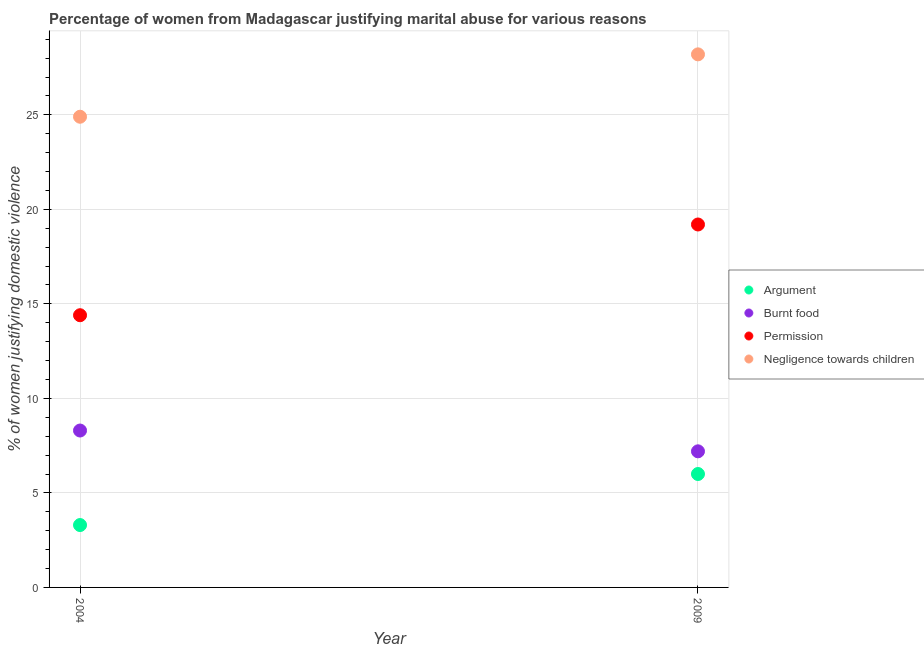How many different coloured dotlines are there?
Make the answer very short. 4. What is the percentage of women justifying abuse for going without permission in 2009?
Make the answer very short. 19.2. In which year was the percentage of women justifying abuse for burning food maximum?
Your answer should be compact. 2004. What is the total percentage of women justifying abuse for showing negligence towards children in the graph?
Your answer should be compact. 53.1. What is the difference between the percentage of women justifying abuse for going without permission in 2004 and that in 2009?
Your answer should be very brief. -4.8. What is the difference between the percentage of women justifying abuse for burning food in 2009 and the percentage of women justifying abuse in the case of an argument in 2004?
Ensure brevity in your answer.  3.9. What is the average percentage of women justifying abuse for burning food per year?
Keep it short and to the point. 7.75. In the year 2009, what is the difference between the percentage of women justifying abuse for going without permission and percentage of women justifying abuse in the case of an argument?
Provide a succinct answer. 13.2. In how many years, is the percentage of women justifying abuse in the case of an argument greater than 24 %?
Make the answer very short. 0. What is the ratio of the percentage of women justifying abuse for showing negligence towards children in 2004 to that in 2009?
Your answer should be compact. 0.88. Is the percentage of women justifying abuse for going without permission in 2004 less than that in 2009?
Offer a terse response. Yes. In how many years, is the percentage of women justifying abuse for burning food greater than the average percentage of women justifying abuse for burning food taken over all years?
Your answer should be very brief. 1. Is it the case that in every year, the sum of the percentage of women justifying abuse for going without permission and percentage of women justifying abuse for showing negligence towards children is greater than the sum of percentage of women justifying abuse for burning food and percentage of women justifying abuse in the case of an argument?
Your answer should be compact. No. Is the percentage of women justifying abuse in the case of an argument strictly less than the percentage of women justifying abuse for going without permission over the years?
Offer a terse response. Yes. How many years are there in the graph?
Offer a terse response. 2. Are the values on the major ticks of Y-axis written in scientific E-notation?
Ensure brevity in your answer.  No. Does the graph contain grids?
Offer a very short reply. Yes. How are the legend labels stacked?
Your response must be concise. Vertical. What is the title of the graph?
Your response must be concise. Percentage of women from Madagascar justifying marital abuse for various reasons. Does "Rule based governance" appear as one of the legend labels in the graph?
Provide a succinct answer. No. What is the label or title of the Y-axis?
Offer a terse response. % of women justifying domestic violence. What is the % of women justifying domestic violence in Negligence towards children in 2004?
Offer a terse response. 24.9. What is the % of women justifying domestic violence in Argument in 2009?
Make the answer very short. 6. What is the % of women justifying domestic violence of Permission in 2009?
Your answer should be compact. 19.2. What is the % of women justifying domestic violence of Negligence towards children in 2009?
Your response must be concise. 28.2. Across all years, what is the maximum % of women justifying domestic violence of Argument?
Your answer should be compact. 6. Across all years, what is the maximum % of women justifying domestic violence of Burnt food?
Your answer should be compact. 8.3. Across all years, what is the maximum % of women justifying domestic violence of Negligence towards children?
Offer a very short reply. 28.2. Across all years, what is the minimum % of women justifying domestic violence in Burnt food?
Provide a succinct answer. 7.2. Across all years, what is the minimum % of women justifying domestic violence of Negligence towards children?
Your answer should be very brief. 24.9. What is the total % of women justifying domestic violence in Argument in the graph?
Offer a terse response. 9.3. What is the total % of women justifying domestic violence in Burnt food in the graph?
Provide a succinct answer. 15.5. What is the total % of women justifying domestic violence of Permission in the graph?
Keep it short and to the point. 33.6. What is the total % of women justifying domestic violence of Negligence towards children in the graph?
Your answer should be very brief. 53.1. What is the difference between the % of women justifying domestic violence of Argument in 2004 and that in 2009?
Offer a very short reply. -2.7. What is the difference between the % of women justifying domestic violence of Negligence towards children in 2004 and that in 2009?
Provide a succinct answer. -3.3. What is the difference between the % of women justifying domestic violence of Argument in 2004 and the % of women justifying domestic violence of Burnt food in 2009?
Provide a succinct answer. -3.9. What is the difference between the % of women justifying domestic violence in Argument in 2004 and the % of women justifying domestic violence in Permission in 2009?
Offer a terse response. -15.9. What is the difference between the % of women justifying domestic violence of Argument in 2004 and the % of women justifying domestic violence of Negligence towards children in 2009?
Your response must be concise. -24.9. What is the difference between the % of women justifying domestic violence in Burnt food in 2004 and the % of women justifying domestic violence in Permission in 2009?
Your answer should be very brief. -10.9. What is the difference between the % of women justifying domestic violence of Burnt food in 2004 and the % of women justifying domestic violence of Negligence towards children in 2009?
Ensure brevity in your answer.  -19.9. What is the difference between the % of women justifying domestic violence in Permission in 2004 and the % of women justifying domestic violence in Negligence towards children in 2009?
Provide a succinct answer. -13.8. What is the average % of women justifying domestic violence in Argument per year?
Keep it short and to the point. 4.65. What is the average % of women justifying domestic violence in Burnt food per year?
Give a very brief answer. 7.75. What is the average % of women justifying domestic violence of Permission per year?
Offer a very short reply. 16.8. What is the average % of women justifying domestic violence in Negligence towards children per year?
Give a very brief answer. 26.55. In the year 2004, what is the difference between the % of women justifying domestic violence in Argument and % of women justifying domestic violence in Burnt food?
Your answer should be compact. -5. In the year 2004, what is the difference between the % of women justifying domestic violence of Argument and % of women justifying domestic violence of Permission?
Keep it short and to the point. -11.1. In the year 2004, what is the difference between the % of women justifying domestic violence of Argument and % of women justifying domestic violence of Negligence towards children?
Provide a short and direct response. -21.6. In the year 2004, what is the difference between the % of women justifying domestic violence of Burnt food and % of women justifying domestic violence of Negligence towards children?
Your response must be concise. -16.6. In the year 2009, what is the difference between the % of women justifying domestic violence in Argument and % of women justifying domestic violence in Burnt food?
Ensure brevity in your answer.  -1.2. In the year 2009, what is the difference between the % of women justifying domestic violence of Argument and % of women justifying domestic violence of Negligence towards children?
Ensure brevity in your answer.  -22.2. In the year 2009, what is the difference between the % of women justifying domestic violence in Burnt food and % of women justifying domestic violence in Permission?
Keep it short and to the point. -12. In the year 2009, what is the difference between the % of women justifying domestic violence in Burnt food and % of women justifying domestic violence in Negligence towards children?
Ensure brevity in your answer.  -21. What is the ratio of the % of women justifying domestic violence in Argument in 2004 to that in 2009?
Your response must be concise. 0.55. What is the ratio of the % of women justifying domestic violence in Burnt food in 2004 to that in 2009?
Offer a very short reply. 1.15. What is the ratio of the % of women justifying domestic violence in Permission in 2004 to that in 2009?
Ensure brevity in your answer.  0.75. What is the ratio of the % of women justifying domestic violence in Negligence towards children in 2004 to that in 2009?
Your answer should be very brief. 0.88. What is the difference between the highest and the second highest % of women justifying domestic violence of Argument?
Provide a short and direct response. 2.7. What is the difference between the highest and the second highest % of women justifying domestic violence of Permission?
Your response must be concise. 4.8. What is the difference between the highest and the lowest % of women justifying domestic violence in Negligence towards children?
Your response must be concise. 3.3. 